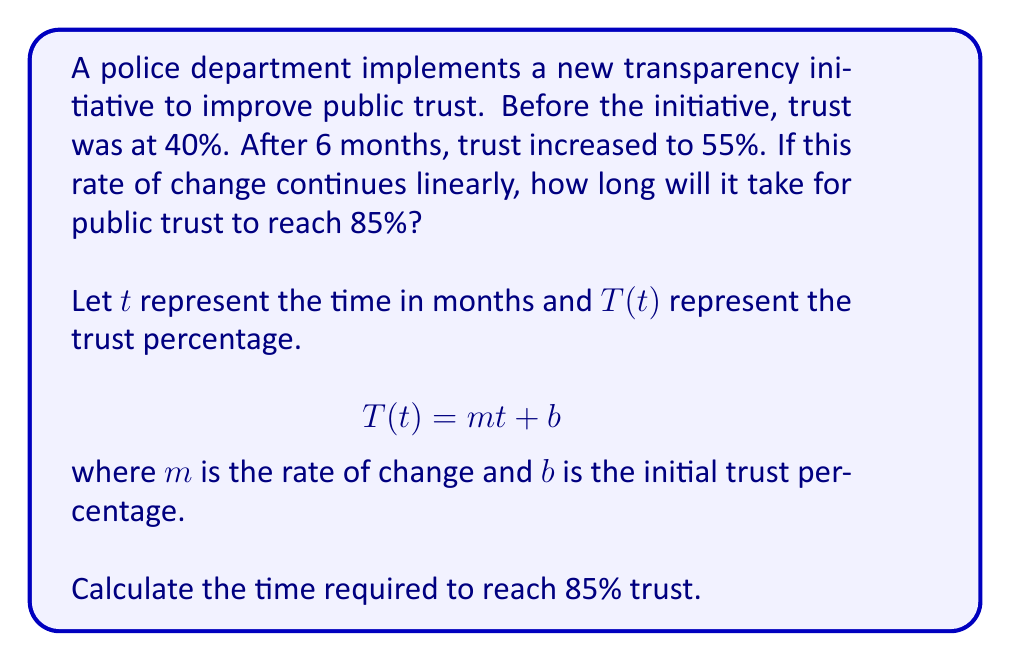Teach me how to tackle this problem. To solve this problem, we'll follow these steps:

1. Calculate the rate of change (slope) $m$:
   $$m = \frac{\text{change in trust}}{\text{change in time}} = \frac{55\% - 40\%}{6\text{ months}} = \frac{15\%}{6\text{ months}} = 2.5\%\text{ per month}$$

2. Write the linear equation:
   $$T(t) = 2.5t + 40$$

3. Solve for $t$ when $T(t) = 85\%$:
   $$85 = 2.5t + 40$$
   $$45 = 2.5t$$
   $$t = \frac{45}{2.5} = 18$$

Therefore, it will take 18 months from the start of the initiative to reach 85% trust.

4. Calculate time from the 6-month mark:
   $18\text{ months} - 6\text{ months} = 12\text{ months}$
Answer: It will take 12 additional months (18 months total from the start of the initiative) for public trust to reach 85%. 